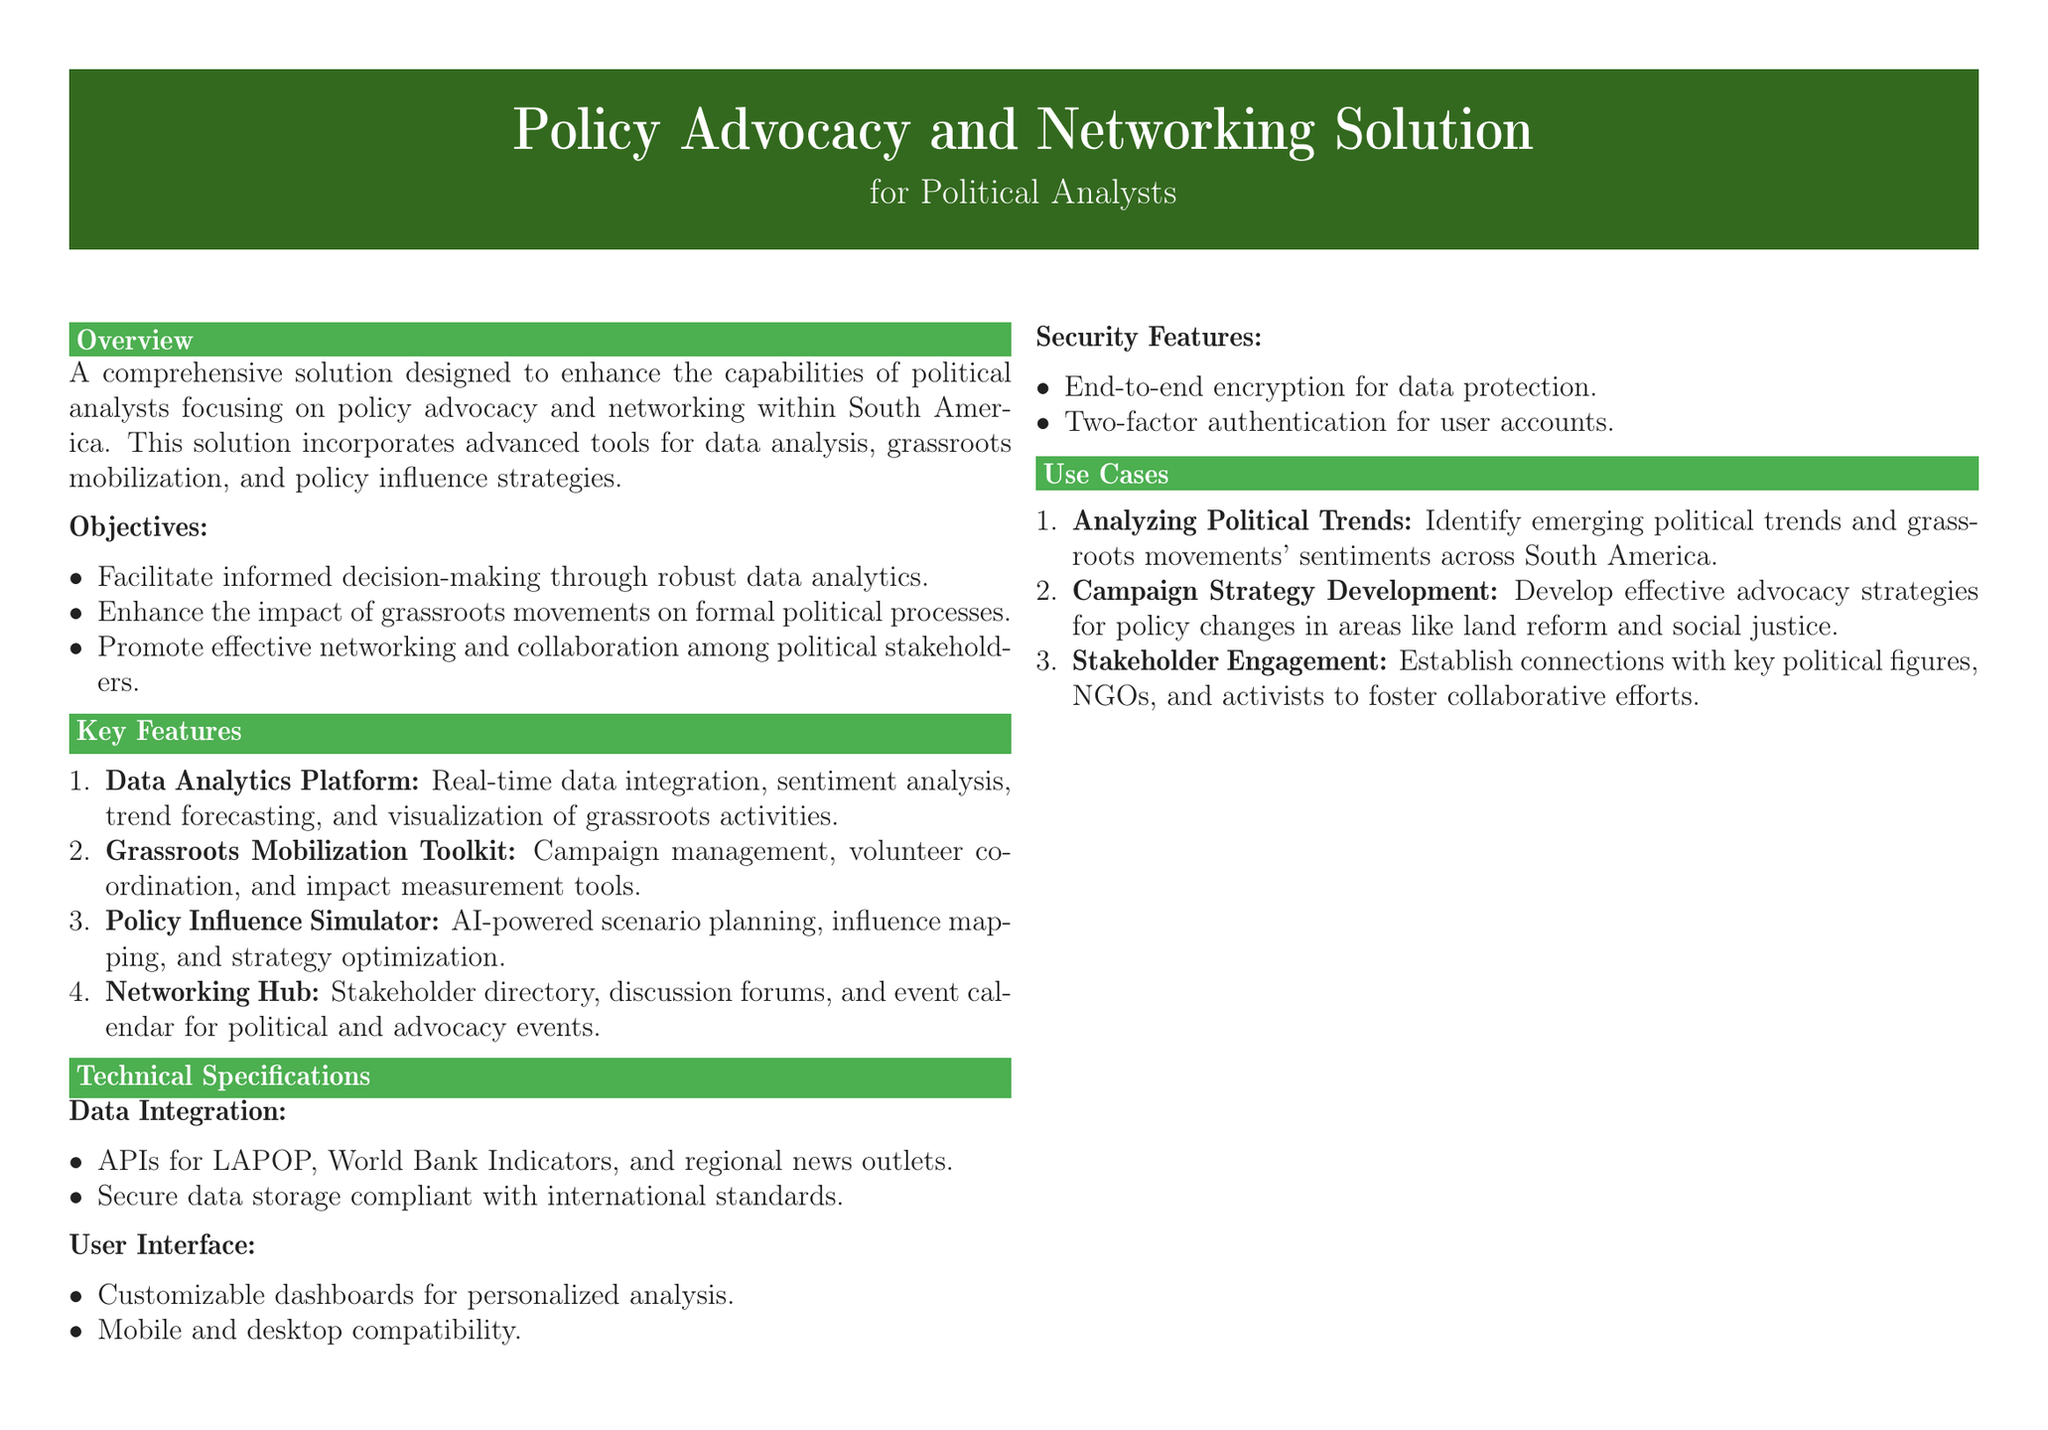What is the title of the document? The title of the document is found at the top of the rendered document, describing the product.
Answer: Policy Advocacy and Networking Solution What type of technology is used for the Data Analytics Platform? The technology involves real-time data integration and analytics, which is specified in the key features section.
Answer: Real-time data integration What is the purpose of the Grassroots Mobilization Toolkit? The toolkit is designed to manage campaigns and coordinate volunteers, as stated in the features section.
Answer: Campaign management How many key functions are listed under the Policy Influence Simulator? The number can be counted in the feature spotlight section that details the functions.
Answer: Three What is one objective of the Policy Advocacy and Networking Solution? The objectives section lists goals to enhance decision-making, among others.
Answer: Facilitate informed decision-making Which feature focuses on stakeholder engagement? The features section specifies the function pertaining to engaging with stakeholders.
Answer: Networking Hub What security feature is implemented for user accounts? The security features section mentions a specific protective measure for accounts.
Answer: Two-factor authentication What is the contact email provided in the document? The document provides contact details, including an email address for inquiries.
Answer: info@advocateplus.com How is data stored according to the technical specifications? The document states the nature of data storage in compliance with specific standards.
Answer: Compliant with international standards 